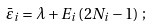<formula> <loc_0><loc_0><loc_500><loc_500>\bar { \varepsilon } _ { i } = \lambda + E _ { i } \left ( 2 N _ { i } - 1 \right ) \, ;</formula> 